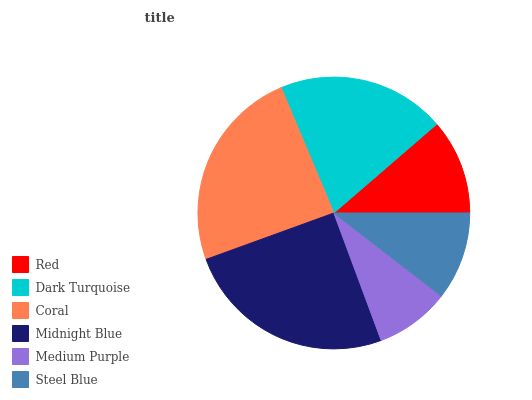Is Medium Purple the minimum?
Answer yes or no. Yes. Is Midnight Blue the maximum?
Answer yes or no. Yes. Is Dark Turquoise the minimum?
Answer yes or no. No. Is Dark Turquoise the maximum?
Answer yes or no. No. Is Dark Turquoise greater than Red?
Answer yes or no. Yes. Is Red less than Dark Turquoise?
Answer yes or no. Yes. Is Red greater than Dark Turquoise?
Answer yes or no. No. Is Dark Turquoise less than Red?
Answer yes or no. No. Is Dark Turquoise the high median?
Answer yes or no. Yes. Is Red the low median?
Answer yes or no. Yes. Is Steel Blue the high median?
Answer yes or no. No. Is Coral the low median?
Answer yes or no. No. 